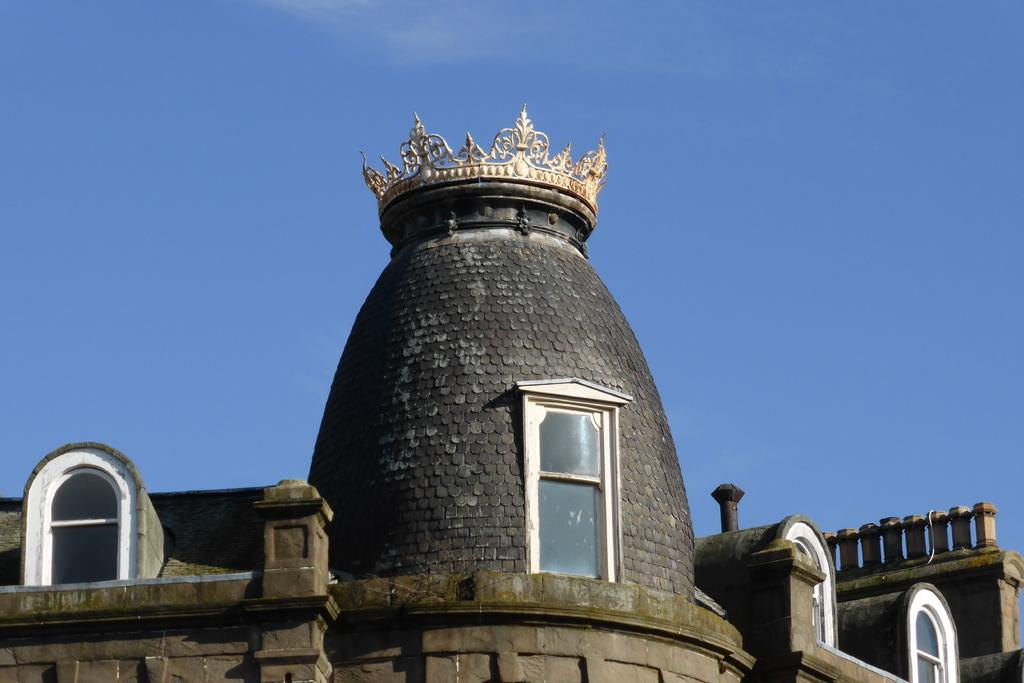What type of structure is visible in the image? There is a building in the image. What specific feature can be seen on the building? There is a black color circular tower on the building. Are there any windows visible on the circular tower? Yes, there is a white color window on the circular tower. What color is the sky in the background of the image? The sky is blue in the background of the image. Can you see the tongue of the person who took the picture in the image? There is no person or tongue visible in the image; it only shows a building with a circular tower and a window. 